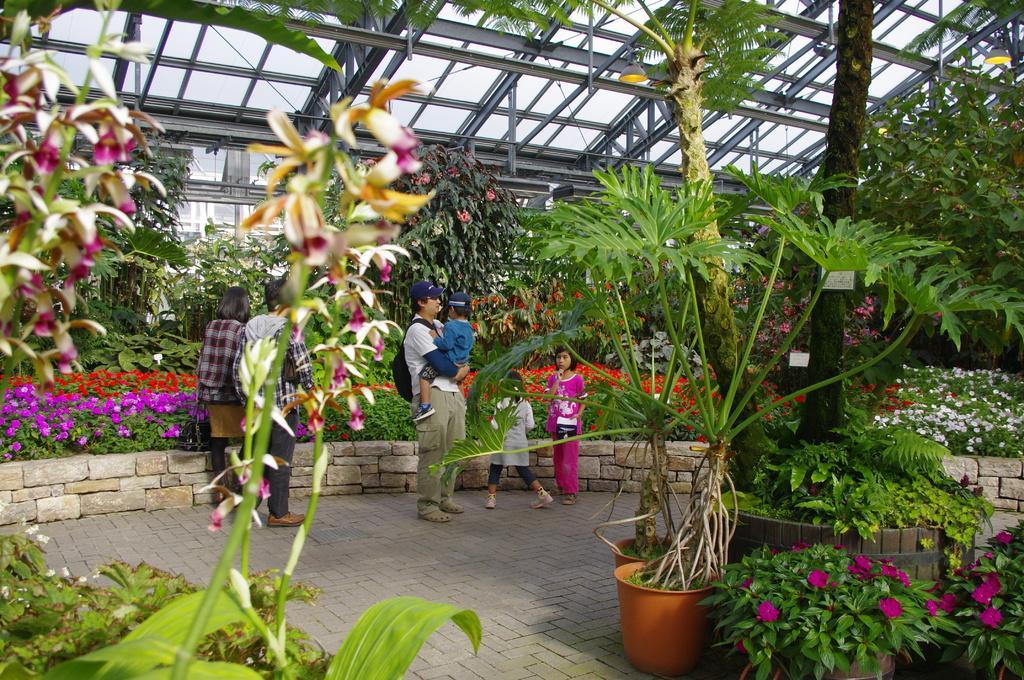Describe this image in one or two sentences. Under this shed there are people and plants. Plants with flowers. This man wore bag and carrying a baby. 